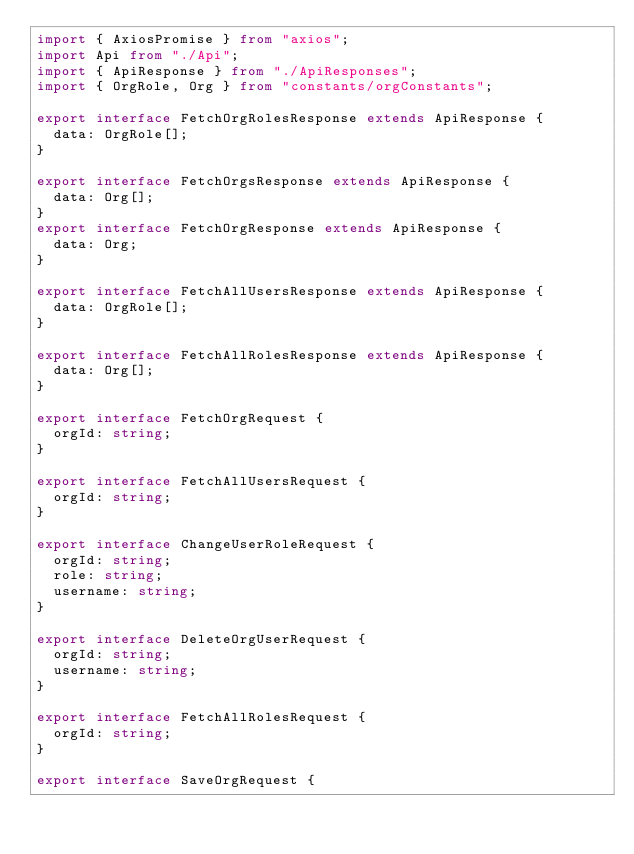<code> <loc_0><loc_0><loc_500><loc_500><_TypeScript_>import { AxiosPromise } from "axios";
import Api from "./Api";
import { ApiResponse } from "./ApiResponses";
import { OrgRole, Org } from "constants/orgConstants";

export interface FetchOrgRolesResponse extends ApiResponse {
  data: OrgRole[];
}

export interface FetchOrgsResponse extends ApiResponse {
  data: Org[];
}
export interface FetchOrgResponse extends ApiResponse {
  data: Org;
}

export interface FetchAllUsersResponse extends ApiResponse {
  data: OrgRole[];
}

export interface FetchAllRolesResponse extends ApiResponse {
  data: Org[];
}

export interface FetchOrgRequest {
  orgId: string;
}

export interface FetchAllUsersRequest {
  orgId: string;
}

export interface ChangeUserRoleRequest {
  orgId: string;
  role: string;
  username: string;
}

export interface DeleteOrgUserRequest {
  orgId: string;
  username: string;
}

export interface FetchAllRolesRequest {
  orgId: string;
}

export interface SaveOrgRequest {</code> 